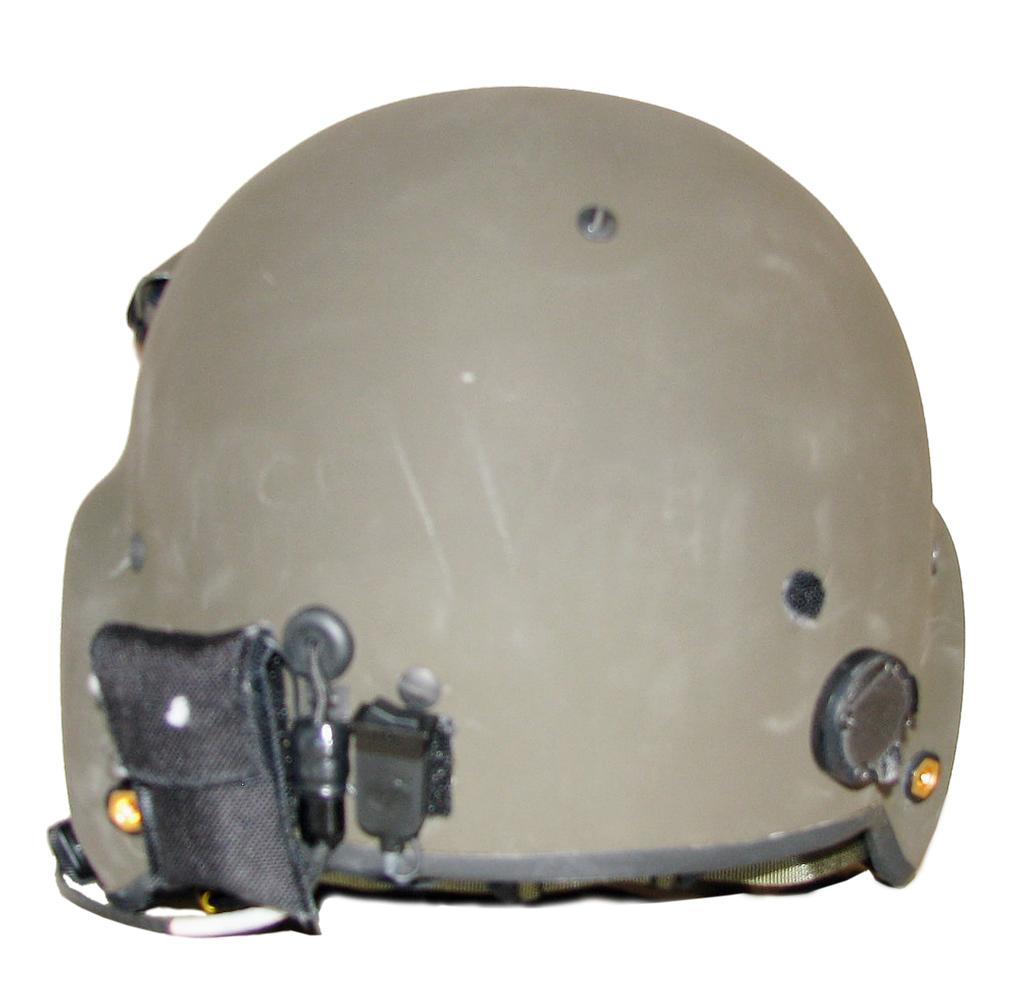What object is the main focus of the image? There is a helmet in the image. Can you describe the colors of the helmet? The helmet is grey and black in color. What is the background of the image? The background of the image is white. What type of teaching material can be seen in the image? There is no teaching material present in the image. 